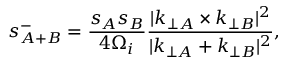<formula> <loc_0><loc_0><loc_500><loc_500>s _ { A + B } ^ { - } = \frac { s _ { A } s _ { B } } { 4 \Omega _ { i } } \frac { | k _ { \perp A } \times k _ { \perp B } | ^ { 2 } } { | k _ { \perp A } + k _ { \perp B } | ^ { 2 } } ,</formula> 